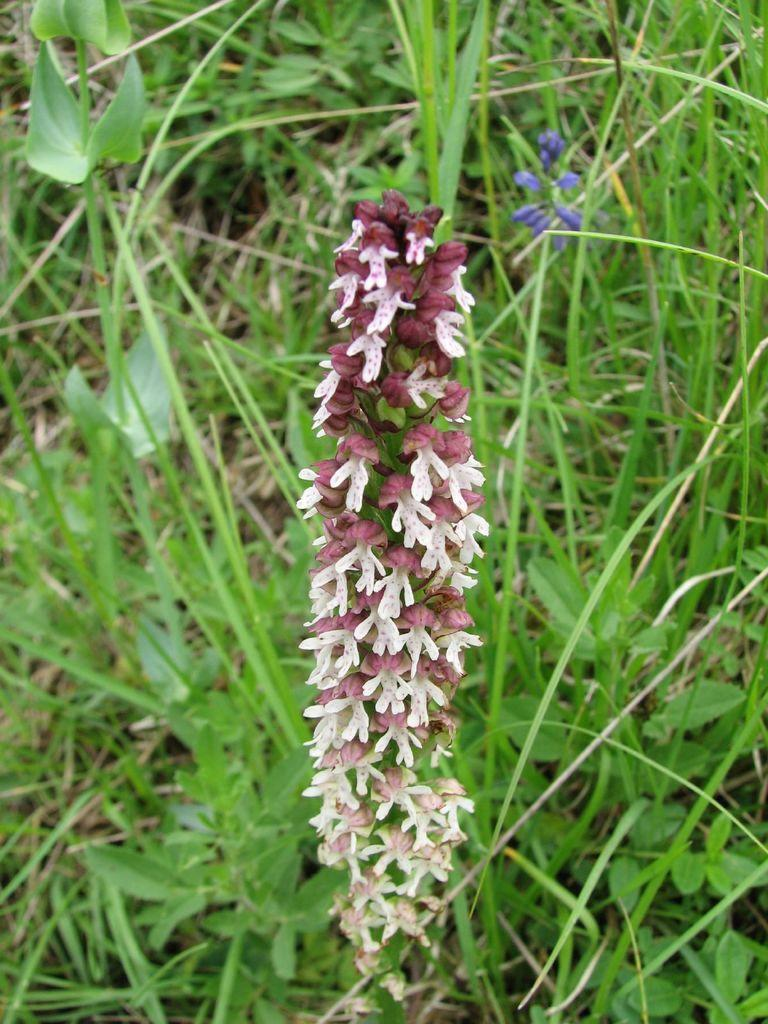What type of flower is in the image? There is a red and white colored flower in the image. What can be seen in the background of the image? There is green grass in the background of the image. How many dogs are playing in the image? There are no dogs present in the image. What is the temper of the flower in the image? Flowers do not have a temper, as they are inanimate objects. 